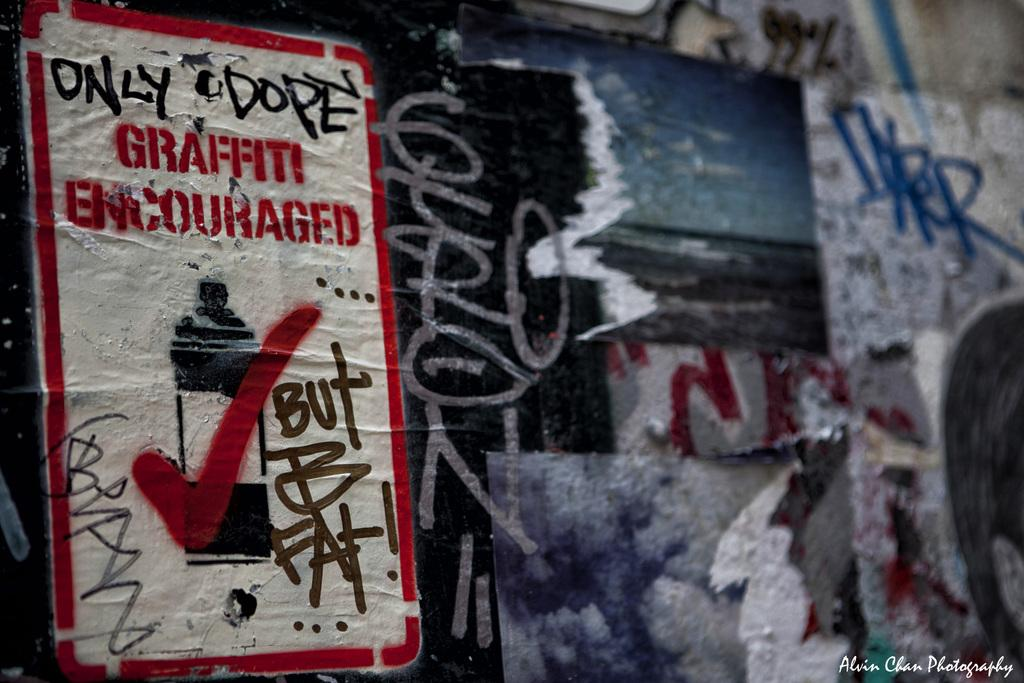Provide a one-sentence caption for the provided image. A bunch of graffiti covering a wall and a poster that says graffiti encouraged. 